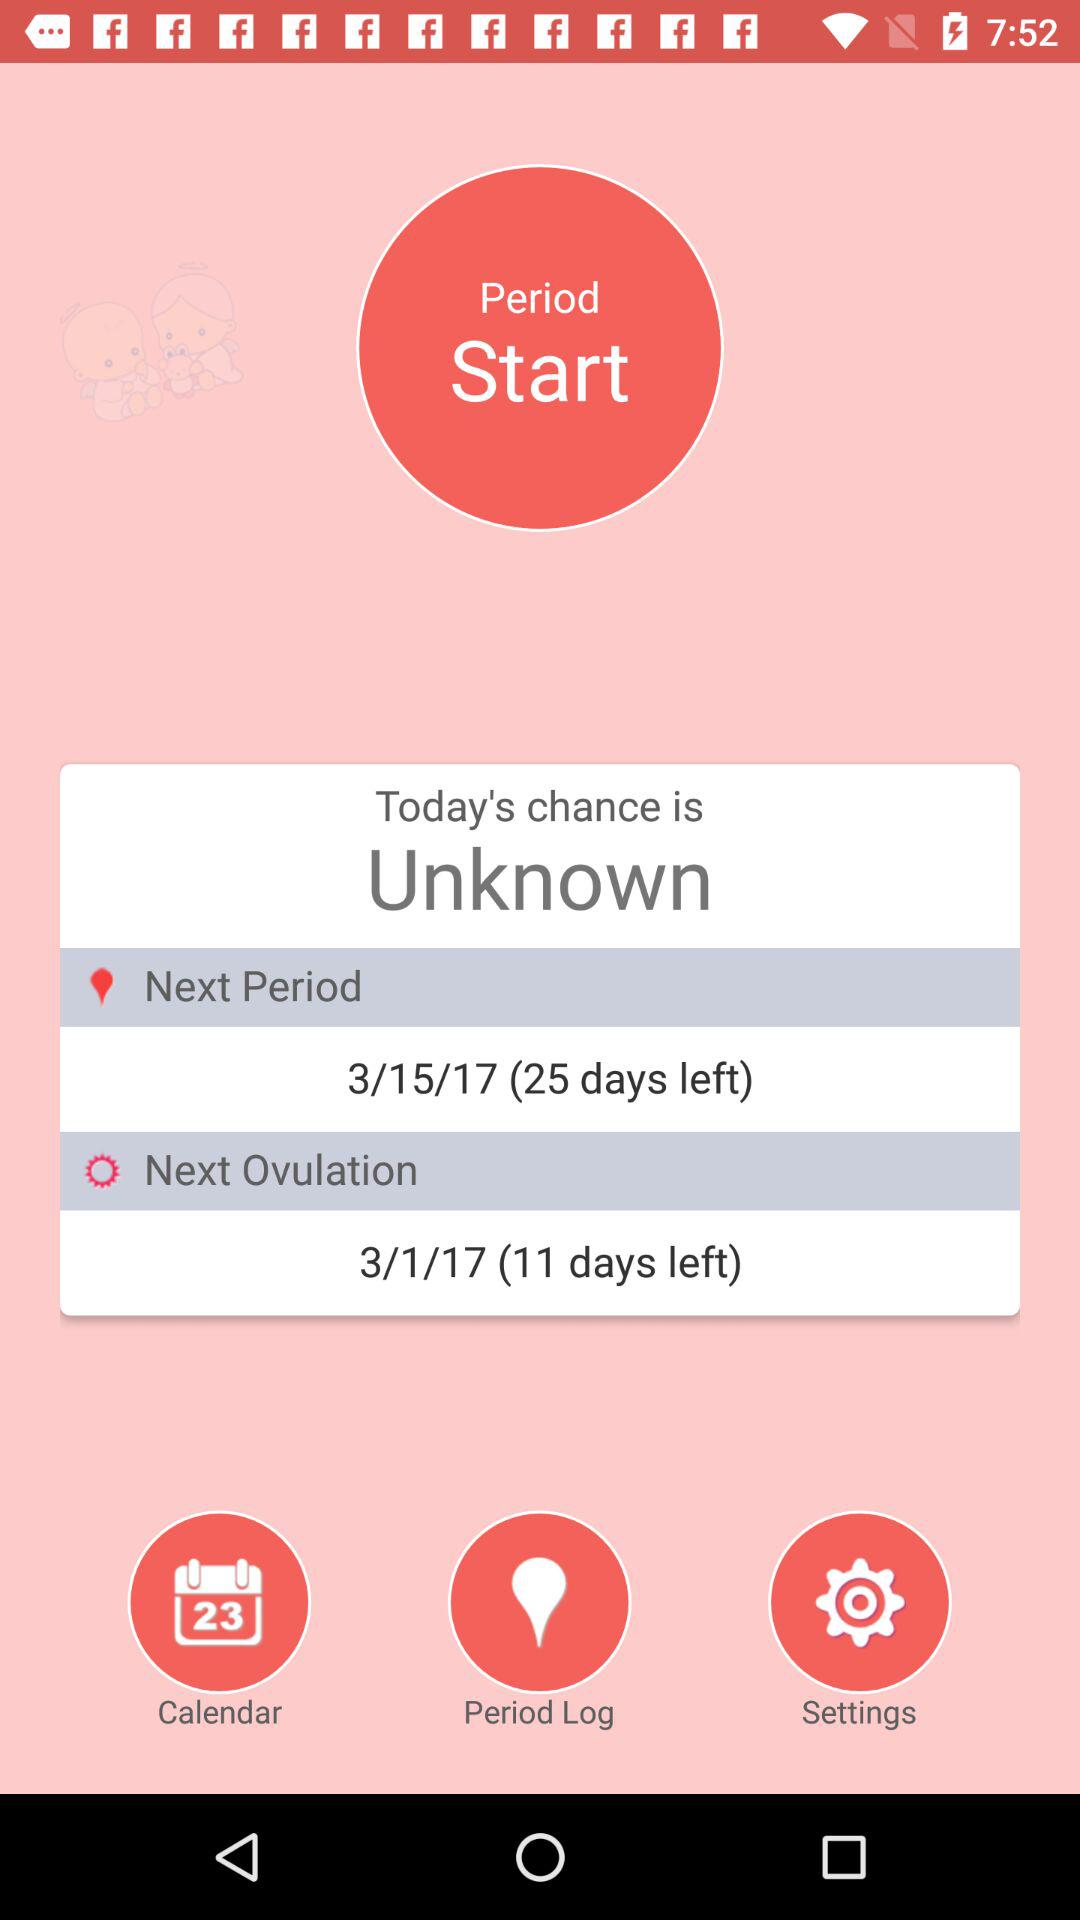How many days are left until the next ovulation? The number of days left until the next ovulation is 11. 